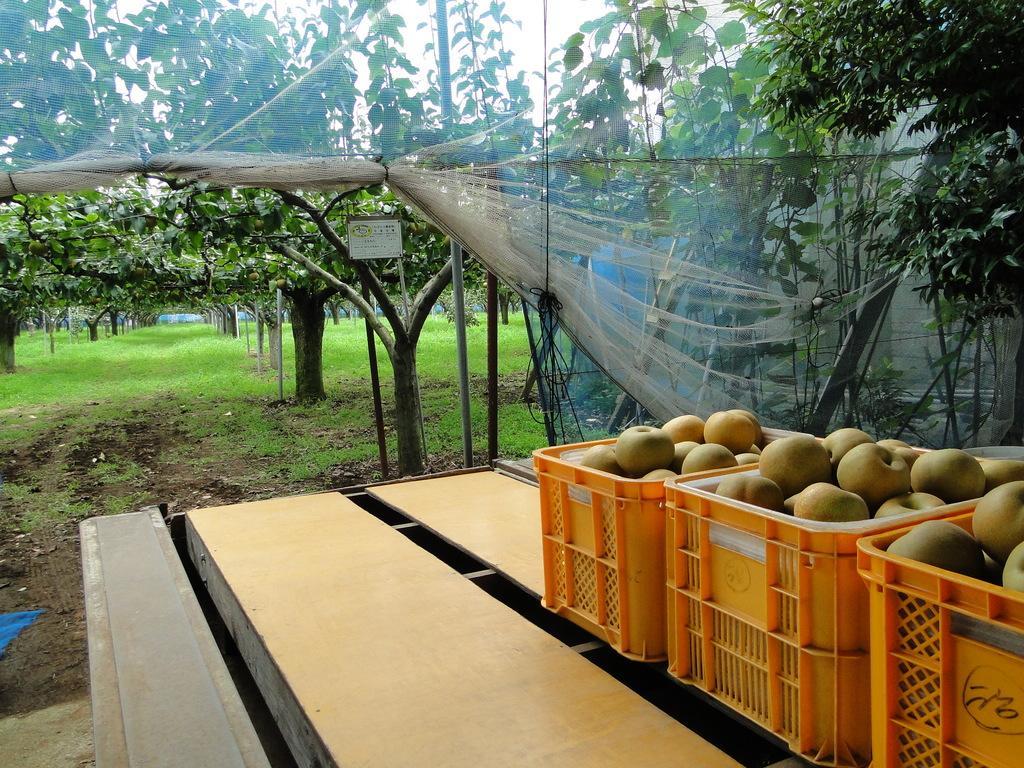How would you summarize this image in a sentence or two? In this image, we can see a table. Few baskets are placed on it. In the baskets, we can see the fruits. Background there are so many trees, grass, poles, board, net and sky. 